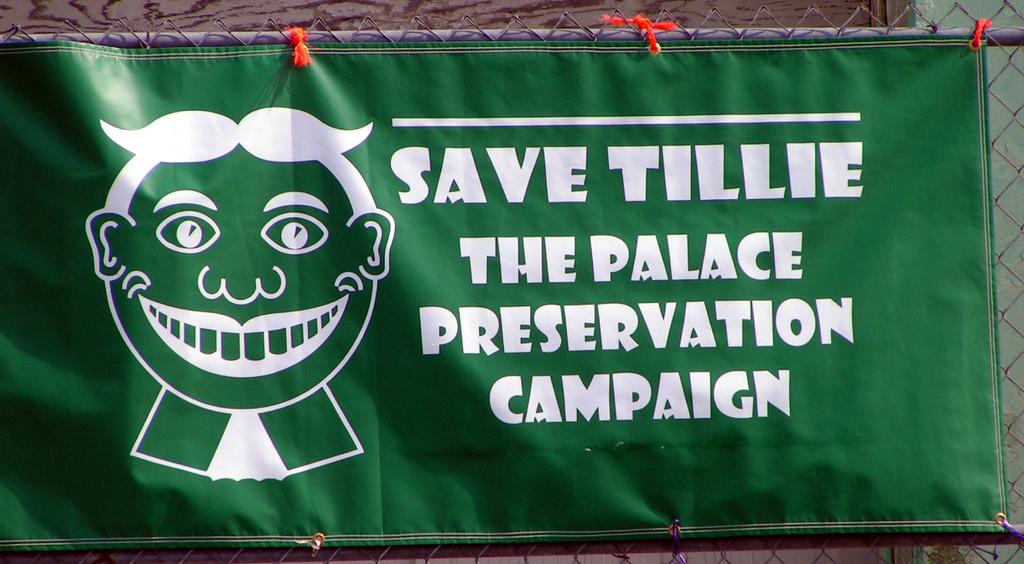What is tillie?
Offer a very short reply. A palace. What type of campaign is on the banner?
Provide a short and direct response. The palace preservation campaign. 